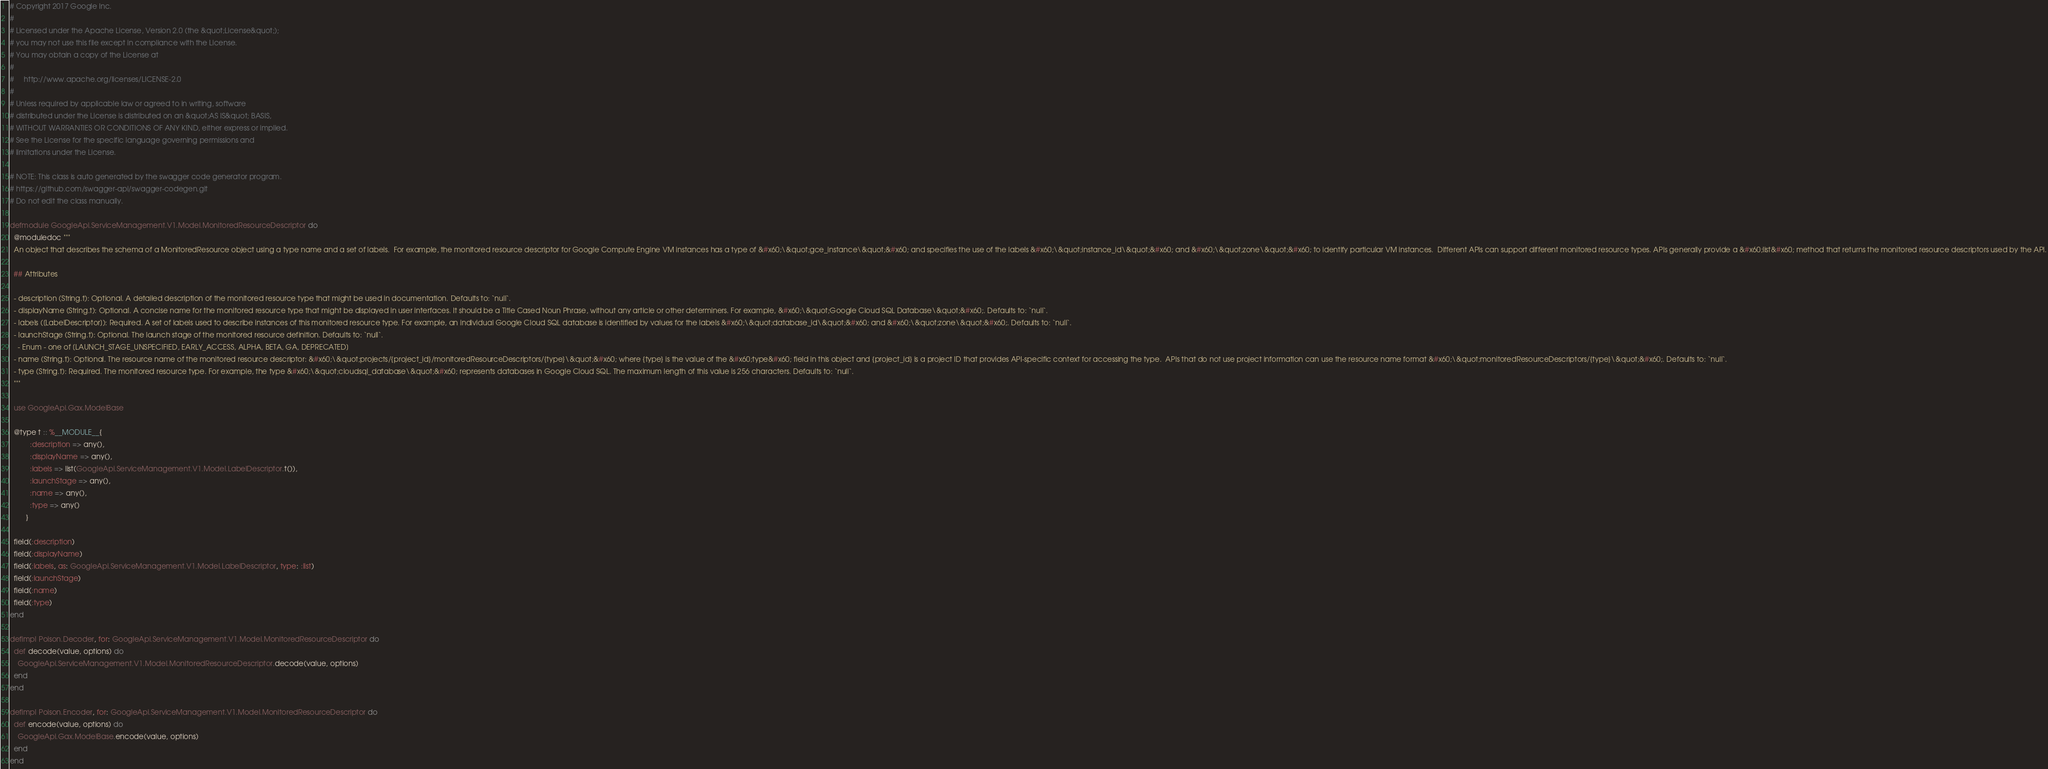<code> <loc_0><loc_0><loc_500><loc_500><_Elixir_># Copyright 2017 Google Inc.
#
# Licensed under the Apache License, Version 2.0 (the &quot;License&quot;);
# you may not use this file except in compliance with the License.
# You may obtain a copy of the License at
#
#     http://www.apache.org/licenses/LICENSE-2.0
#
# Unless required by applicable law or agreed to in writing, software
# distributed under the License is distributed on an &quot;AS IS&quot; BASIS,
# WITHOUT WARRANTIES OR CONDITIONS OF ANY KIND, either express or implied.
# See the License for the specific language governing permissions and
# limitations under the License.

# NOTE: This class is auto generated by the swagger code generator program.
# https://github.com/swagger-api/swagger-codegen.git
# Do not edit the class manually.

defmodule GoogleApi.ServiceManagement.V1.Model.MonitoredResourceDescriptor do
  @moduledoc """
  An object that describes the schema of a MonitoredResource object using a type name and a set of labels.  For example, the monitored resource descriptor for Google Compute Engine VM instances has a type of &#x60;\&quot;gce_instance\&quot;&#x60; and specifies the use of the labels &#x60;\&quot;instance_id\&quot;&#x60; and &#x60;\&quot;zone\&quot;&#x60; to identify particular VM instances.  Different APIs can support different monitored resource types. APIs generally provide a &#x60;list&#x60; method that returns the monitored resource descriptors used by the API.

  ## Attributes

  - description (String.t): Optional. A detailed description of the monitored resource type that might be used in documentation. Defaults to: `null`.
  - displayName (String.t): Optional. A concise name for the monitored resource type that might be displayed in user interfaces. It should be a Title Cased Noun Phrase, without any article or other determiners. For example, &#x60;\&quot;Google Cloud SQL Database\&quot;&#x60;. Defaults to: `null`.
  - labels ([LabelDescriptor]): Required. A set of labels used to describe instances of this monitored resource type. For example, an individual Google Cloud SQL database is identified by values for the labels &#x60;\&quot;database_id\&quot;&#x60; and &#x60;\&quot;zone\&quot;&#x60;. Defaults to: `null`.
  - launchStage (String.t): Optional. The launch stage of the monitored resource definition. Defaults to: `null`.
    - Enum - one of [LAUNCH_STAGE_UNSPECIFIED, EARLY_ACCESS, ALPHA, BETA, GA, DEPRECATED]
  - name (String.t): Optional. The resource name of the monitored resource descriptor: &#x60;\&quot;projects/{project_id}/monitoredResourceDescriptors/{type}\&quot;&#x60; where {type} is the value of the &#x60;type&#x60; field in this object and {project_id} is a project ID that provides API-specific context for accessing the type.  APIs that do not use project information can use the resource name format &#x60;\&quot;monitoredResourceDescriptors/{type}\&quot;&#x60;. Defaults to: `null`.
  - type (String.t): Required. The monitored resource type. For example, the type &#x60;\&quot;cloudsql_database\&quot;&#x60; represents databases in Google Cloud SQL. The maximum length of this value is 256 characters. Defaults to: `null`.
  """

  use GoogleApi.Gax.ModelBase

  @type t :: %__MODULE__{
          :description => any(),
          :displayName => any(),
          :labels => list(GoogleApi.ServiceManagement.V1.Model.LabelDescriptor.t()),
          :launchStage => any(),
          :name => any(),
          :type => any()
        }

  field(:description)
  field(:displayName)
  field(:labels, as: GoogleApi.ServiceManagement.V1.Model.LabelDescriptor, type: :list)
  field(:launchStage)
  field(:name)
  field(:type)
end

defimpl Poison.Decoder, for: GoogleApi.ServiceManagement.V1.Model.MonitoredResourceDescriptor do
  def decode(value, options) do
    GoogleApi.ServiceManagement.V1.Model.MonitoredResourceDescriptor.decode(value, options)
  end
end

defimpl Poison.Encoder, for: GoogleApi.ServiceManagement.V1.Model.MonitoredResourceDescriptor do
  def encode(value, options) do
    GoogleApi.Gax.ModelBase.encode(value, options)
  end
end
</code> 